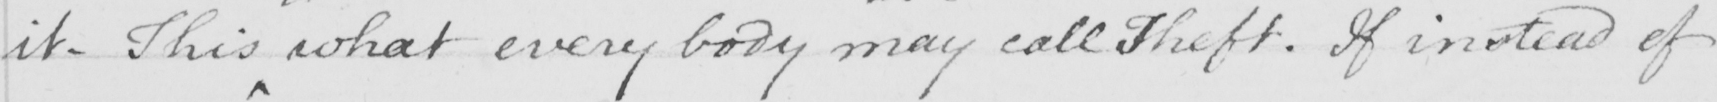Please provide the text content of this handwritten line. it . This what every body may  call Theft . If instead of 